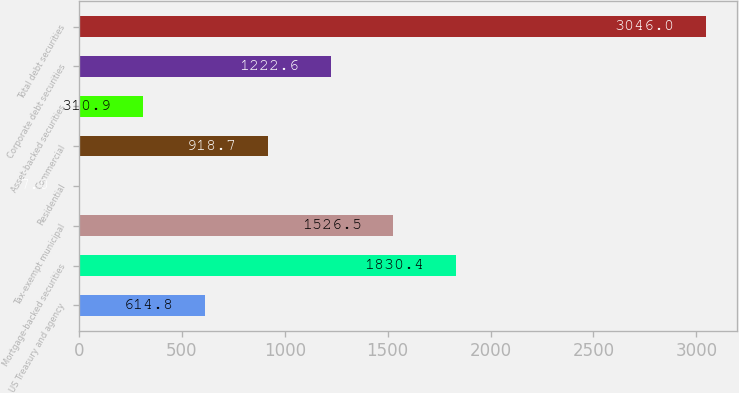Convert chart. <chart><loc_0><loc_0><loc_500><loc_500><bar_chart><fcel>US Treasury and agency<fcel>Mortgage-backed securities<fcel>Tax-exempt municipal<fcel>Residential<fcel>Commercial<fcel>Asset-backed securities<fcel>Corporate debt securities<fcel>Total debt securities<nl><fcel>614.8<fcel>1830.4<fcel>1526.5<fcel>7<fcel>918.7<fcel>310.9<fcel>1222.6<fcel>3046<nl></chart> 